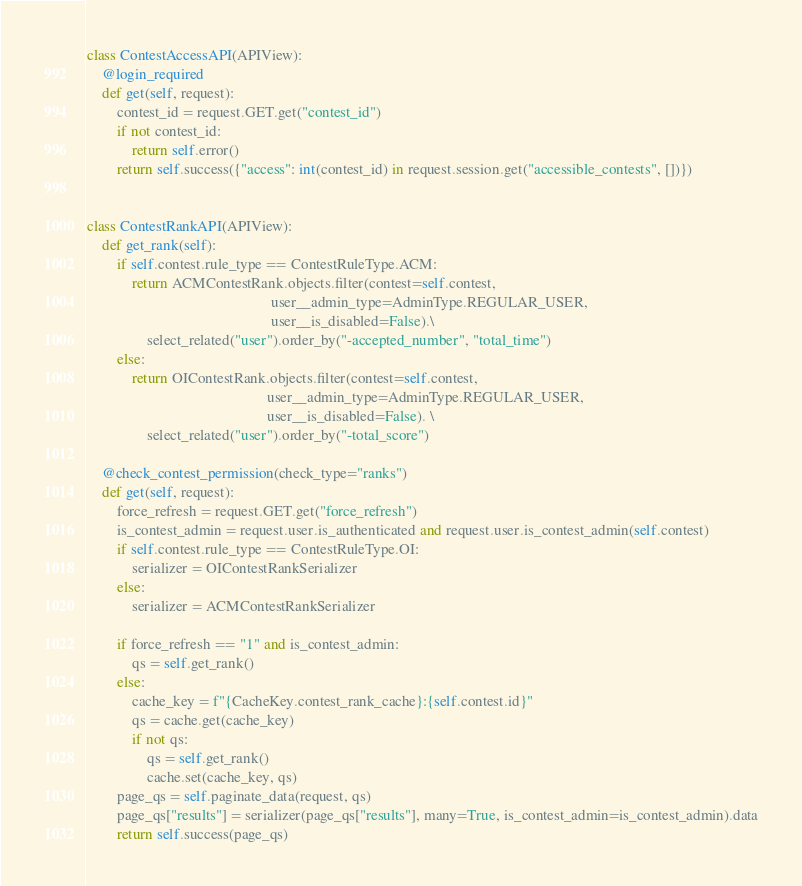Convert code to text. <code><loc_0><loc_0><loc_500><loc_500><_Python_>class ContestAccessAPI(APIView):
    @login_required
    def get(self, request):
        contest_id = request.GET.get("contest_id")
        if not contest_id:
            return self.error()
        return self.success({"access": int(contest_id) in request.session.get("accessible_contests", [])})


class ContestRankAPI(APIView):
    def get_rank(self):
        if self.contest.rule_type == ContestRuleType.ACM:
            return ACMContestRank.objects.filter(contest=self.contest,
                                                 user__admin_type=AdminType.REGULAR_USER,
                                                 user__is_disabled=False).\
                select_related("user").order_by("-accepted_number", "total_time")
        else:
            return OIContestRank.objects.filter(contest=self.contest,
                                                user__admin_type=AdminType.REGULAR_USER,
                                                user__is_disabled=False). \
                select_related("user").order_by("-total_score")

    @check_contest_permission(check_type="ranks")
    def get(self, request):
        force_refresh = request.GET.get("force_refresh")
        is_contest_admin = request.user.is_authenticated and request.user.is_contest_admin(self.contest)
        if self.contest.rule_type == ContestRuleType.OI:
            serializer = OIContestRankSerializer
        else:
            serializer = ACMContestRankSerializer

        if force_refresh == "1" and is_contest_admin:
            qs = self.get_rank()
        else:
            cache_key = f"{CacheKey.contest_rank_cache}:{self.contest.id}"
            qs = cache.get(cache_key)
            if not qs:
                qs = self.get_rank()
                cache.set(cache_key, qs)
        page_qs = self.paginate_data(request, qs)
        page_qs["results"] = serializer(page_qs["results"], many=True, is_contest_admin=is_contest_admin).data
        return self.success(page_qs)
</code> 